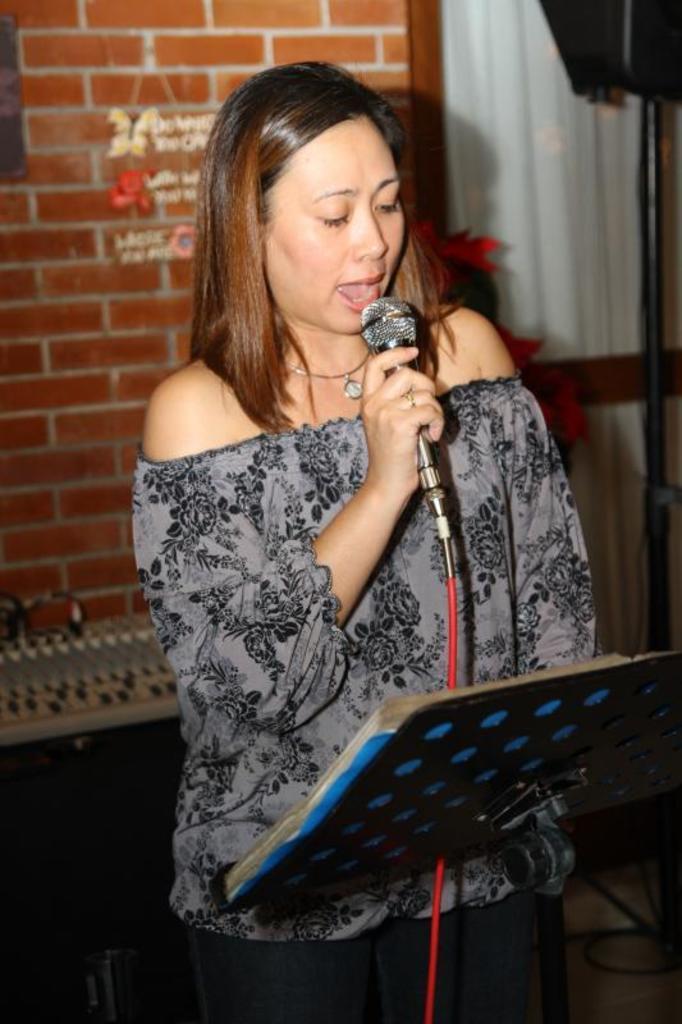Please provide a concise description of this image. In this image a woman standing and singing holding a micro phone in front of a women there is a stand a book on it at the back ground i can see a brick wall and a curtain. 